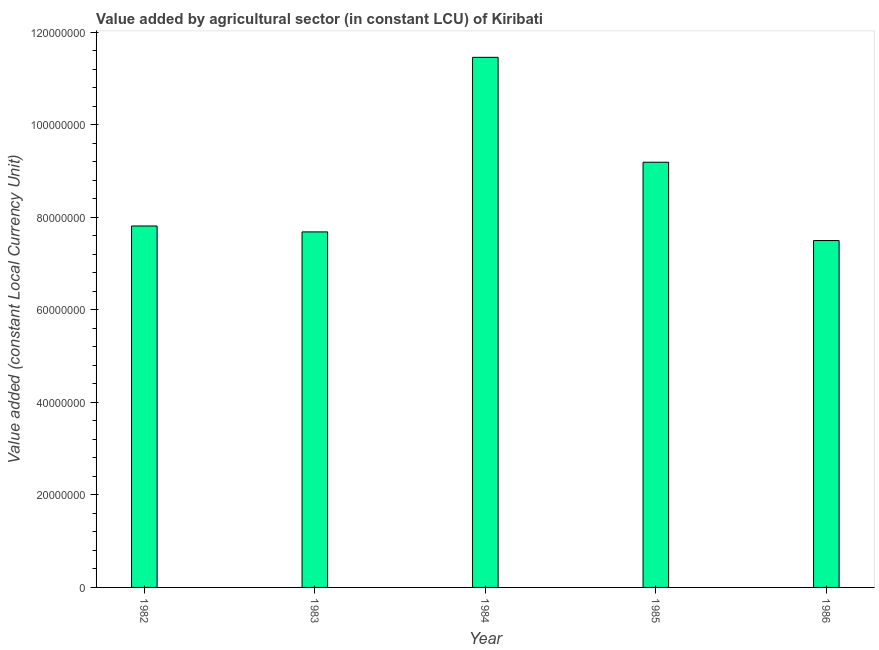Does the graph contain any zero values?
Provide a short and direct response. No. Does the graph contain grids?
Offer a very short reply. No. What is the title of the graph?
Make the answer very short. Value added by agricultural sector (in constant LCU) of Kiribati. What is the label or title of the X-axis?
Your response must be concise. Year. What is the label or title of the Y-axis?
Your response must be concise. Value added (constant Local Currency Unit). What is the value added by agriculture sector in 1984?
Your answer should be very brief. 1.15e+08. Across all years, what is the maximum value added by agriculture sector?
Keep it short and to the point. 1.15e+08. Across all years, what is the minimum value added by agriculture sector?
Your answer should be very brief. 7.49e+07. In which year was the value added by agriculture sector maximum?
Make the answer very short. 1984. What is the sum of the value added by agriculture sector?
Give a very brief answer. 4.36e+08. What is the difference between the value added by agriculture sector in 1985 and 1986?
Keep it short and to the point. 1.69e+07. What is the average value added by agriculture sector per year?
Your answer should be compact. 8.73e+07. What is the median value added by agriculture sector?
Make the answer very short. 7.81e+07. In how many years, is the value added by agriculture sector greater than 68000000 LCU?
Your answer should be very brief. 5. What is the ratio of the value added by agriculture sector in 1985 to that in 1986?
Provide a short and direct response. 1.23. Is the value added by agriculture sector in 1982 less than that in 1983?
Provide a short and direct response. No. Is the difference between the value added by agriculture sector in 1983 and 1984 greater than the difference between any two years?
Your answer should be very brief. No. What is the difference between the highest and the second highest value added by agriculture sector?
Make the answer very short. 2.27e+07. What is the difference between the highest and the lowest value added by agriculture sector?
Offer a terse response. 3.96e+07. In how many years, is the value added by agriculture sector greater than the average value added by agriculture sector taken over all years?
Keep it short and to the point. 2. How many bars are there?
Offer a very short reply. 5. Are all the bars in the graph horizontal?
Keep it short and to the point. No. What is the difference between two consecutive major ticks on the Y-axis?
Provide a short and direct response. 2.00e+07. What is the Value added (constant Local Currency Unit) of 1982?
Offer a terse response. 7.81e+07. What is the Value added (constant Local Currency Unit) of 1983?
Your answer should be compact. 7.68e+07. What is the Value added (constant Local Currency Unit) in 1984?
Provide a succinct answer. 1.15e+08. What is the Value added (constant Local Currency Unit) of 1985?
Give a very brief answer. 9.19e+07. What is the Value added (constant Local Currency Unit) of 1986?
Give a very brief answer. 7.49e+07. What is the difference between the Value added (constant Local Currency Unit) in 1982 and 1983?
Give a very brief answer. 1.28e+06. What is the difference between the Value added (constant Local Currency Unit) in 1982 and 1984?
Your answer should be compact. -3.64e+07. What is the difference between the Value added (constant Local Currency Unit) in 1982 and 1985?
Make the answer very short. -1.38e+07. What is the difference between the Value added (constant Local Currency Unit) in 1982 and 1986?
Keep it short and to the point. 3.15e+06. What is the difference between the Value added (constant Local Currency Unit) in 1983 and 1984?
Ensure brevity in your answer.  -3.77e+07. What is the difference between the Value added (constant Local Currency Unit) in 1983 and 1985?
Your response must be concise. -1.51e+07. What is the difference between the Value added (constant Local Currency Unit) in 1983 and 1986?
Offer a terse response. 1.87e+06. What is the difference between the Value added (constant Local Currency Unit) in 1984 and 1985?
Give a very brief answer. 2.27e+07. What is the difference between the Value added (constant Local Currency Unit) in 1984 and 1986?
Offer a very short reply. 3.96e+07. What is the difference between the Value added (constant Local Currency Unit) in 1985 and 1986?
Offer a very short reply. 1.69e+07. What is the ratio of the Value added (constant Local Currency Unit) in 1982 to that in 1984?
Give a very brief answer. 0.68. What is the ratio of the Value added (constant Local Currency Unit) in 1982 to that in 1985?
Offer a very short reply. 0.85. What is the ratio of the Value added (constant Local Currency Unit) in 1982 to that in 1986?
Provide a short and direct response. 1.04. What is the ratio of the Value added (constant Local Currency Unit) in 1983 to that in 1984?
Your answer should be compact. 0.67. What is the ratio of the Value added (constant Local Currency Unit) in 1983 to that in 1985?
Give a very brief answer. 0.84. What is the ratio of the Value added (constant Local Currency Unit) in 1984 to that in 1985?
Offer a terse response. 1.25. What is the ratio of the Value added (constant Local Currency Unit) in 1984 to that in 1986?
Your response must be concise. 1.53. What is the ratio of the Value added (constant Local Currency Unit) in 1985 to that in 1986?
Your response must be concise. 1.23. 